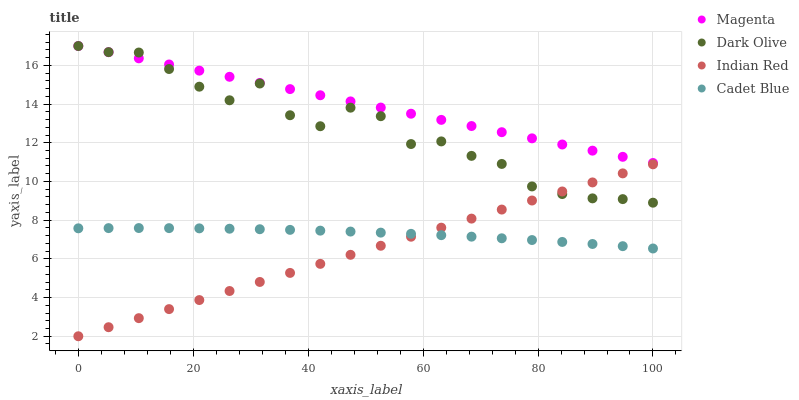Does Indian Red have the minimum area under the curve?
Answer yes or no. Yes. Does Magenta have the maximum area under the curve?
Answer yes or no. Yes. Does Dark Olive have the minimum area under the curve?
Answer yes or no. No. Does Dark Olive have the maximum area under the curve?
Answer yes or no. No. Is Indian Red the smoothest?
Answer yes or no. Yes. Is Dark Olive the roughest?
Answer yes or no. Yes. Is Magenta the smoothest?
Answer yes or no. No. Is Magenta the roughest?
Answer yes or no. No. Does Indian Red have the lowest value?
Answer yes or no. Yes. Does Dark Olive have the lowest value?
Answer yes or no. No. Does Dark Olive have the highest value?
Answer yes or no. Yes. Does Indian Red have the highest value?
Answer yes or no. No. Is Cadet Blue less than Magenta?
Answer yes or no. Yes. Is Magenta greater than Cadet Blue?
Answer yes or no. Yes. Does Indian Red intersect Cadet Blue?
Answer yes or no. Yes. Is Indian Red less than Cadet Blue?
Answer yes or no. No. Is Indian Red greater than Cadet Blue?
Answer yes or no. No. Does Cadet Blue intersect Magenta?
Answer yes or no. No. 